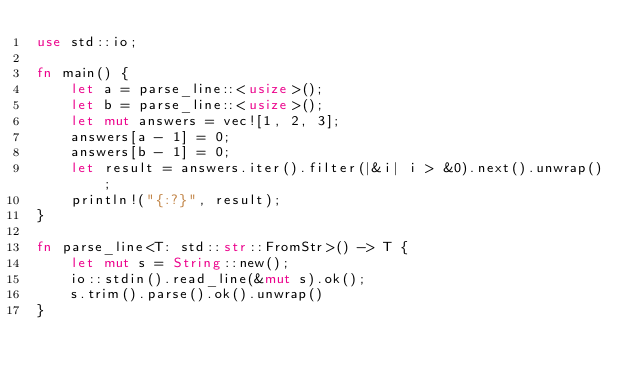Convert code to text. <code><loc_0><loc_0><loc_500><loc_500><_Rust_>use std::io;

fn main() {
    let a = parse_line::<usize>();
    let b = parse_line::<usize>();
    let mut answers = vec![1, 2, 3];
    answers[a - 1] = 0;
    answers[b - 1] = 0;
    let result = answers.iter().filter(|&i| i > &0).next().unwrap();
    println!("{:?}", result);
}

fn parse_line<T: std::str::FromStr>() -> T {
    let mut s = String::new();
    io::stdin().read_line(&mut s).ok();
    s.trim().parse().ok().unwrap()
}</code> 